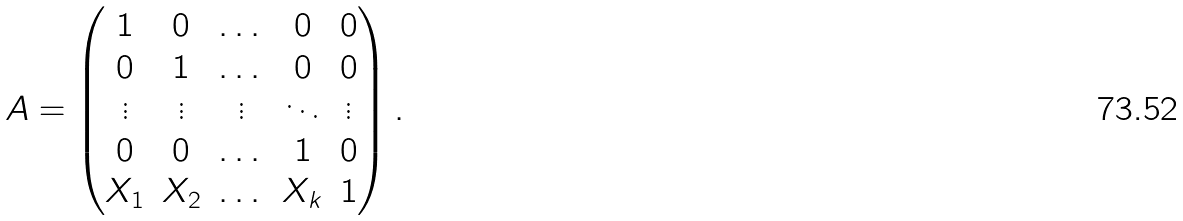<formula> <loc_0><loc_0><loc_500><loc_500>A = \left ( \begin{matrix} 1 & 0 & \dots & 0 & 0 \\ 0 & 1 & \dots & 0 & 0 \\ \vdots & \vdots & \vdots & \ddots & \vdots \\ 0 & 0 & \dots & 1 & 0 \\ X _ { 1 } & X _ { 2 } & \dots & X _ { k } & 1 \\ \end{matrix} \right ) .</formula> 